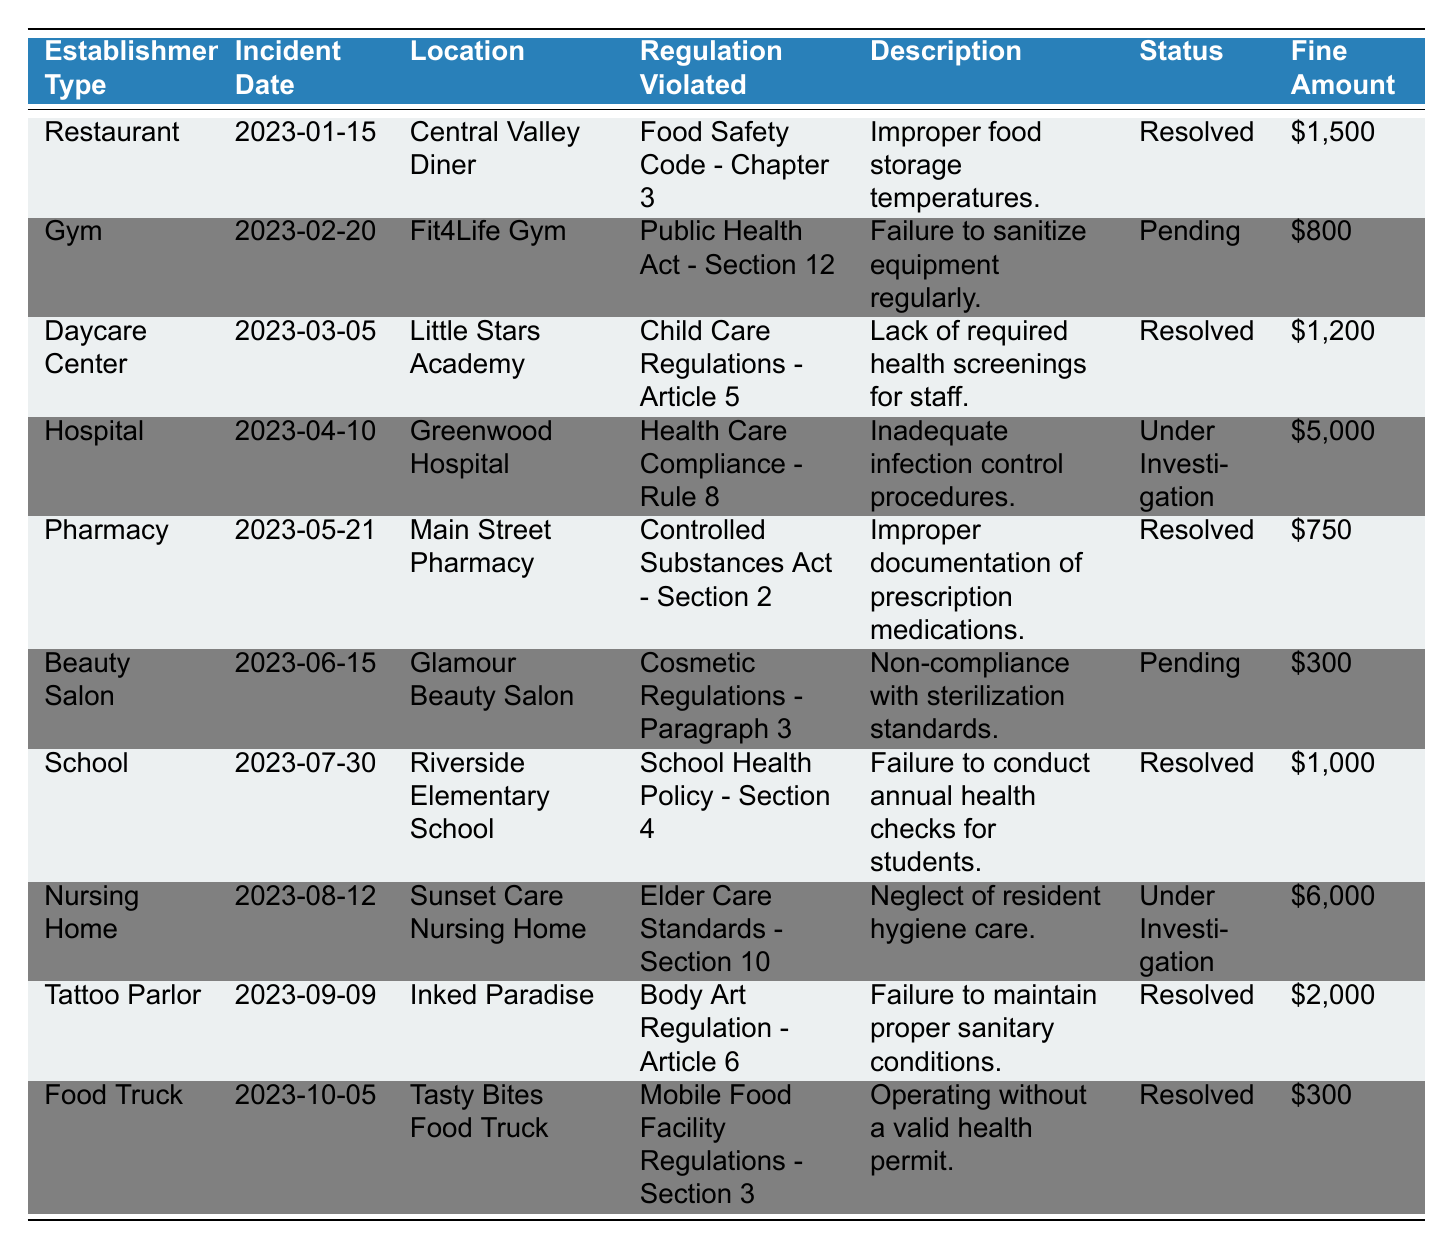What is the total fine amount for all resolved incidents? There are six resolved incidents: Restaurant ($1500), Daycare Center ($1200), Pharmacy ($750), School ($1000), Tattoo Parlor ($2000), and Food Truck ($300). Adding these fines gives us: 1500 + 1200 + 750 + 1000 + 2000 + 300 = 5750.
Answer: 5750 Which establishment has the highest fine amount and what is the amount? The Nursing Home has an unresolved incident with the highest fine amount of $6000. Checking other incident amounts reveals that they are lower than this figure, confirming it to be the highest.
Answer: Nursing Home, $6000 How many establishments are currently under investigation for health violations? There are two establishments listed with a status of 'Under Investigation': Greenwood Hospital and Sunset Care Nursing Home. Counting these gives us a total of 2.
Answer: 2 Is there any incident involving a Gym? If so, what was the fine amount? Yes, there is an incident involving a Gym (Fit4Life Gym) with a fine amount of $800. This information is corroborated by locating the entry for the Gym in the table.
Answer: Yes, $800 What percentage of incidents are still pending resolution? There are 10 total incidents and 3 of them are pending (Gym and Beauty Salon). The percentage is calculated as (3/10) * 100 = 30%.
Answer: 30% How many different establishment types reported violations? The table lists violations from 10 different establishment types: Restaurant, Gym, Daycare Center, Hospital, Pharmacy, Beauty Salon, School, Nursing Home, Tattoo Parlor, and Food Truck. By counting these types, we find there are 10.
Answer: 10 What was the average fine amount for all incidents? The total of all fines is: 1500 + 800 + 1200 + 5000 + 750 + 300 + 1000 + 6000 + 2000 + 300 = 18,050. There are 10 incidents, so the average is 18,050 / 10 = 1805.
Answer: 1805 Is there a fine for the Beauty Salon incident? Yes, the Beauty Salon incident (Glamour Beauty Salon) has a fine amount of $300. This information is directly found in the table.
Answer: Yes, $300 What is the status of the incident at Little Stars Academy? The status of the incident at Little Stars Academy is 'Resolved'. This information is located in the appropriate row within the table.
Answer: Resolved Which establishments have incidents with a fine exceeding $2000? There are three establishments with fines exceeding $2000: Greenwood Hospital ($5000), Sunset Care Nursing Home ($6000), and Inked Paradise ($2000). After reviewing the amounts, only Greenwood Hospital and Sunset Care Nursing Home exceed $2000.
Answer: Greenwood Hospital, Sunset Care Nursing Home 